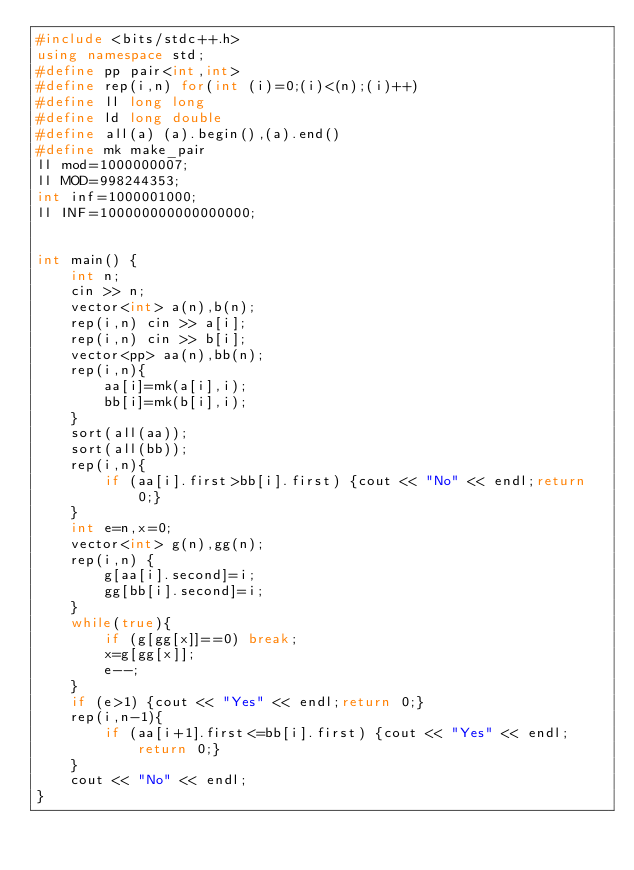Convert code to text. <code><loc_0><loc_0><loc_500><loc_500><_C++_>#include <bits/stdc++.h>
using namespace std;
#define pp pair<int,int>
#define rep(i,n) for(int (i)=0;(i)<(n);(i)++)
#define ll long long
#define ld long double
#define all(a) (a).begin(),(a).end()
#define mk make_pair
ll mod=1000000007;
ll MOD=998244353;
int inf=1000001000;
ll INF=100000000000000000;


int main() {
    int n;
    cin >> n;
    vector<int> a(n),b(n);
    rep(i,n) cin >> a[i];
    rep(i,n) cin >> b[i];
    vector<pp> aa(n),bb(n);
    rep(i,n){
        aa[i]=mk(a[i],i);
        bb[i]=mk(b[i],i);
    }
    sort(all(aa));
    sort(all(bb));
    rep(i,n){
        if (aa[i].first>bb[i].first) {cout << "No" << endl;return 0;}
    }
    int e=n,x=0;
    vector<int> g(n),gg(n);
    rep(i,n) {
        g[aa[i].second]=i;
        gg[bb[i].second]=i;
    }
    while(true){
        if (g[gg[x]]==0) break;
        x=g[gg[x]];
        e--;
    }
    if (e>1) {cout << "Yes" << endl;return 0;}
    rep(i,n-1){
        if (aa[i+1].first<=bb[i].first) {cout << "Yes" << endl;return 0;}
    }
    cout << "No" << endl;
}
</code> 